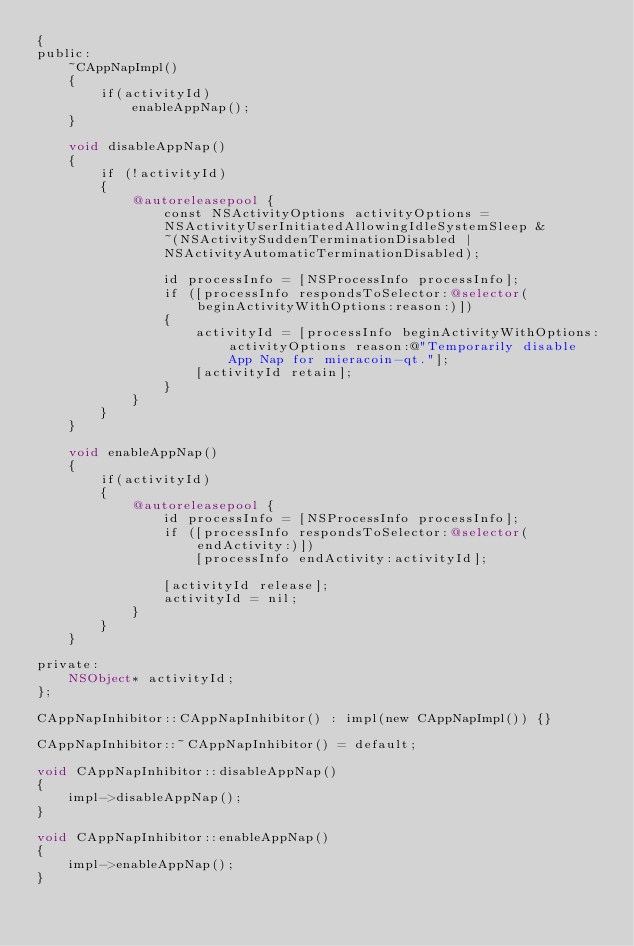<code> <loc_0><loc_0><loc_500><loc_500><_ObjectiveC_>{
public:
    ~CAppNapImpl()
    {
        if(activityId)
            enableAppNap();
    }

    void disableAppNap()
    {
        if (!activityId)
        {
            @autoreleasepool {
                const NSActivityOptions activityOptions =
                NSActivityUserInitiatedAllowingIdleSystemSleep &
                ~(NSActivitySuddenTerminationDisabled |
                NSActivityAutomaticTerminationDisabled);

                id processInfo = [NSProcessInfo processInfo];
                if ([processInfo respondsToSelector:@selector(beginActivityWithOptions:reason:)])
                {
                    activityId = [processInfo beginActivityWithOptions: activityOptions reason:@"Temporarily disable App Nap for mieracoin-qt."];
                    [activityId retain];
                }
            }
        }
    }

    void enableAppNap()
    {
        if(activityId)
        {
            @autoreleasepool {
                id processInfo = [NSProcessInfo processInfo];
                if ([processInfo respondsToSelector:@selector(endActivity:)])
                    [processInfo endActivity:activityId];

                [activityId release];
                activityId = nil;
            }
        }
    }

private:
    NSObject* activityId;
};

CAppNapInhibitor::CAppNapInhibitor() : impl(new CAppNapImpl()) {}

CAppNapInhibitor::~CAppNapInhibitor() = default;

void CAppNapInhibitor::disableAppNap()
{
    impl->disableAppNap();
}

void CAppNapInhibitor::enableAppNap()
{
    impl->enableAppNap();
}
</code> 